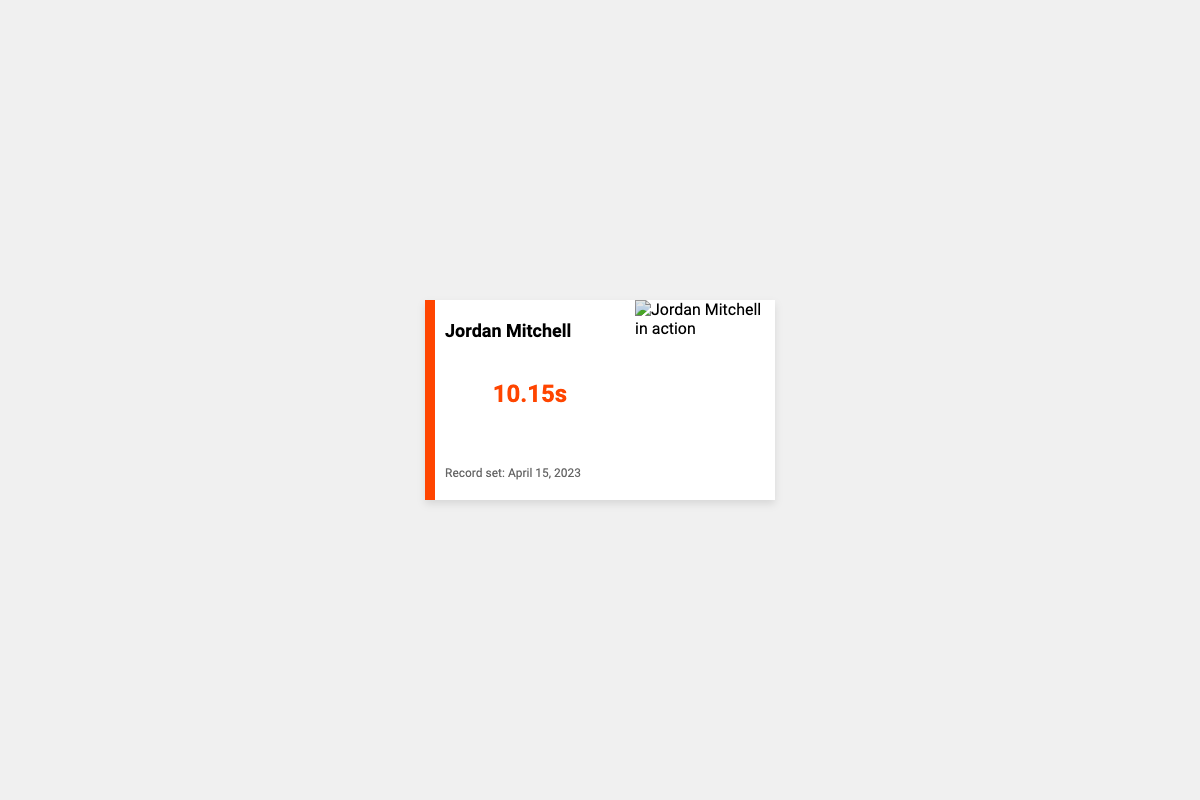What is the name on the business card? The name displayed prominently at the top of the business card is "Jordan Mitchell."
Answer: Jordan Mitchell What is the 100-meter dash record? The document states the record time achieved in the 100-meter dash is shown as "10.15s."
Answer: 10.15s When was the record set? The date on the business card indicates when the record was achieved as "April 15, 2023."
Answer: April 15, 2023 What color is the stripe on the business card? The stripe's color is specified as "FF4500," which is a shade of orange.
Answer: Orange What percentage of the business card is allocated for the image section? The image section covers "40%" of the business card's width.
Answer: 40% Who might be the intended audience for this business card? The minimalist design and athletic record suggest it targets sports professionals, coaches, or recruiters.
Answer: Coaches or recruiters What effect is applied to the image on the business card? The image has a filter applied that enhances "contrast" and "brightness."
Answer: Contrast and brightness What is the overall design style of the business card? The design style of the business card is described as "minimalist."
Answer: Minimalist What is the font name used on the business card? The font used for the text elements on the card is "Roboto."
Answer: Roboto 